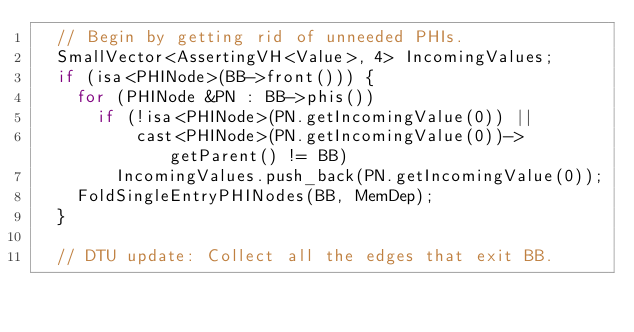<code> <loc_0><loc_0><loc_500><loc_500><_C++_>  // Begin by getting rid of unneeded PHIs.
  SmallVector<AssertingVH<Value>, 4> IncomingValues;
  if (isa<PHINode>(BB->front())) {
    for (PHINode &PN : BB->phis())
      if (!isa<PHINode>(PN.getIncomingValue(0)) ||
          cast<PHINode>(PN.getIncomingValue(0))->getParent() != BB)
        IncomingValues.push_back(PN.getIncomingValue(0));
    FoldSingleEntryPHINodes(BB, MemDep);
  }

  // DTU update: Collect all the edges that exit BB.</code> 